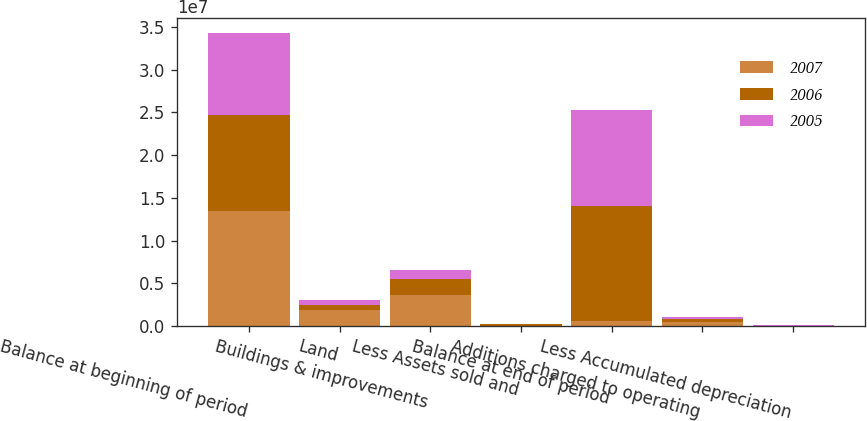Convert chart to OTSL. <chart><loc_0><loc_0><loc_500><loc_500><stacked_bar_chart><ecel><fcel>Balance at beginning of period<fcel>Land<fcel>Buildings & improvements<fcel>Less Assets sold and<fcel>Balance at end of period<fcel>Additions charged to operating<fcel>Less Accumulated depreciation<nl><fcel>2007<fcel>1.34334e+07<fcel>1.9566e+06<fcel>3.61788e+06<fcel>35417<fcel>570764<fcel>445150<fcel>20801<nl><fcel>2006<fcel>1.1252e+07<fcel>552381<fcel>1.86088e+06<fcel>231924<fcel>1.34334e+07<fcel>353473<fcel>45071<nl><fcel>2005<fcel>9.58943e+06<fcel>589148<fcel>1.10336e+06<fcel>29910<fcel>1.1252e+07<fcel>296633<fcel>36961<nl></chart> 